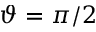Convert formula to latex. <formula><loc_0><loc_0><loc_500><loc_500>\vartheta = \pi / 2</formula> 